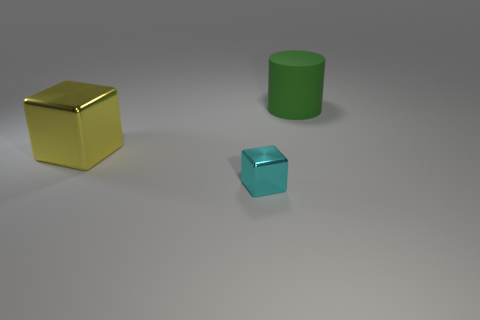Add 2 cyan shiny objects. How many objects exist? 5 Subtract all cubes. How many objects are left? 1 Subtract 0 brown cylinders. How many objects are left? 3 Subtract all big purple blocks. Subtract all large blocks. How many objects are left? 2 Add 3 large blocks. How many large blocks are left? 4 Add 2 tiny gray shiny blocks. How many tiny gray shiny blocks exist? 2 